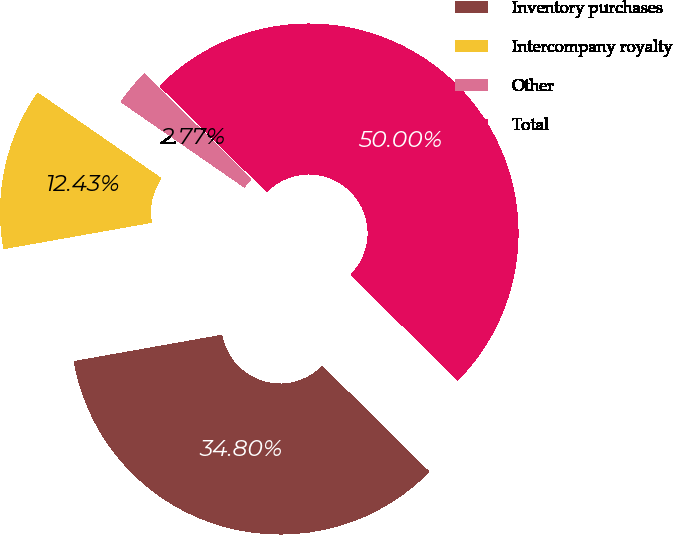Convert chart. <chart><loc_0><loc_0><loc_500><loc_500><pie_chart><fcel>Inventory purchases<fcel>Intercompany royalty<fcel>Other<fcel>Total<nl><fcel>34.8%<fcel>12.43%<fcel>2.77%<fcel>50.0%<nl></chart> 